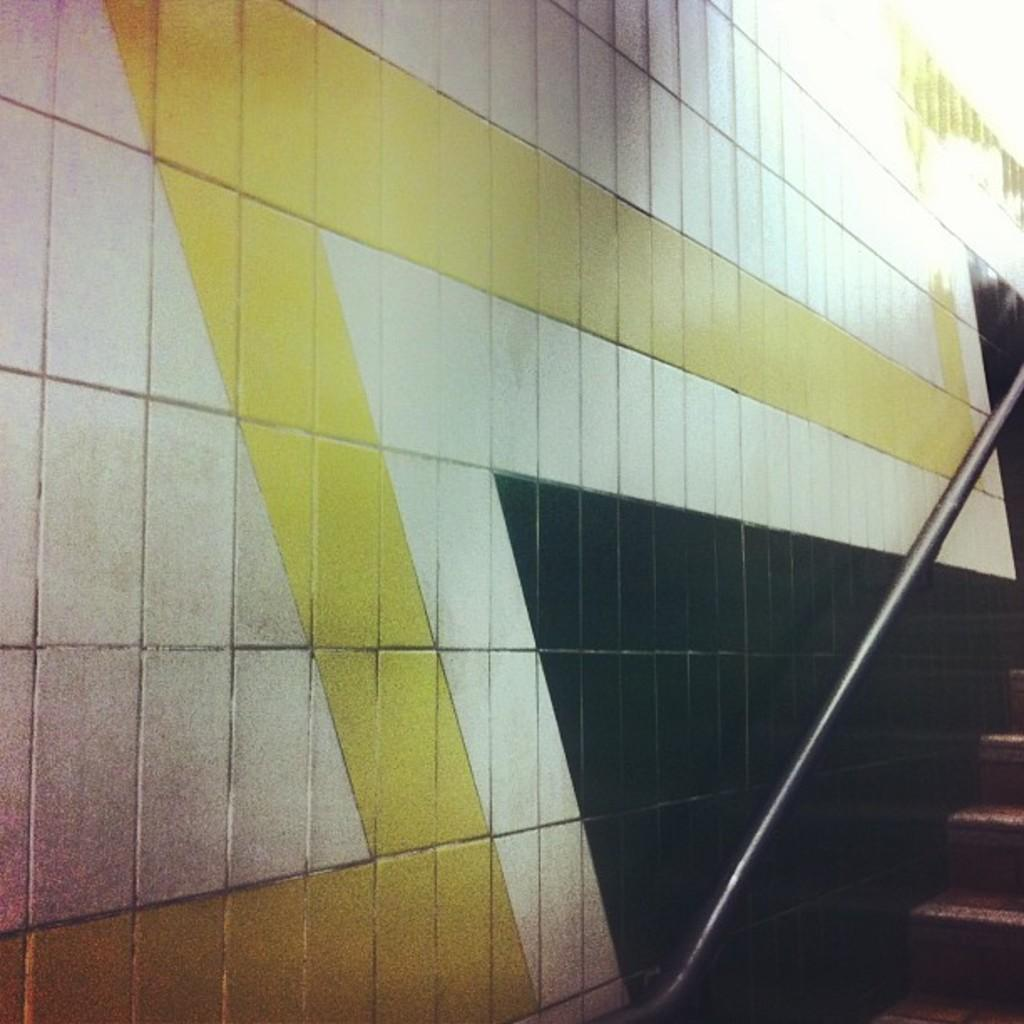What can be seen in the foreground of the image? In the foreground of the image, there are stairs, a railing pole, and a wall. What is the purpose of the railing pole? The railing pole is likely there for safety and support while using the stairs. How many elements are present in the foreground of the image? There are three elements present in the foreground: stairs, a railing pole, and a wall. What type of marble is being used to construct the stairs in the image? There is no mention of marble in the image, and the stairs appear to be made of a different material. 